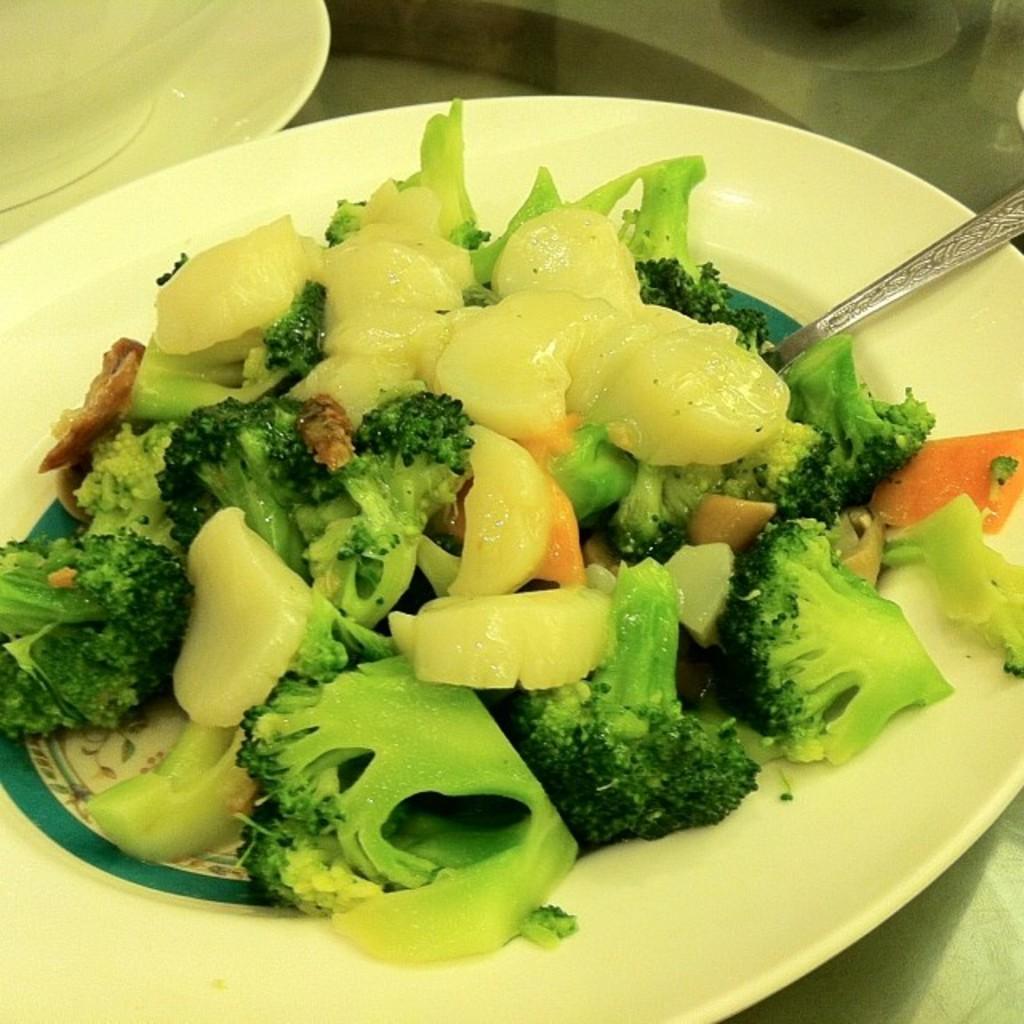Could you give a brief overview of what you see in this image? In this image I can see two plates and on the plate I can see a food item which is green, orange and cream in color. I can see a spoon on the plate. 